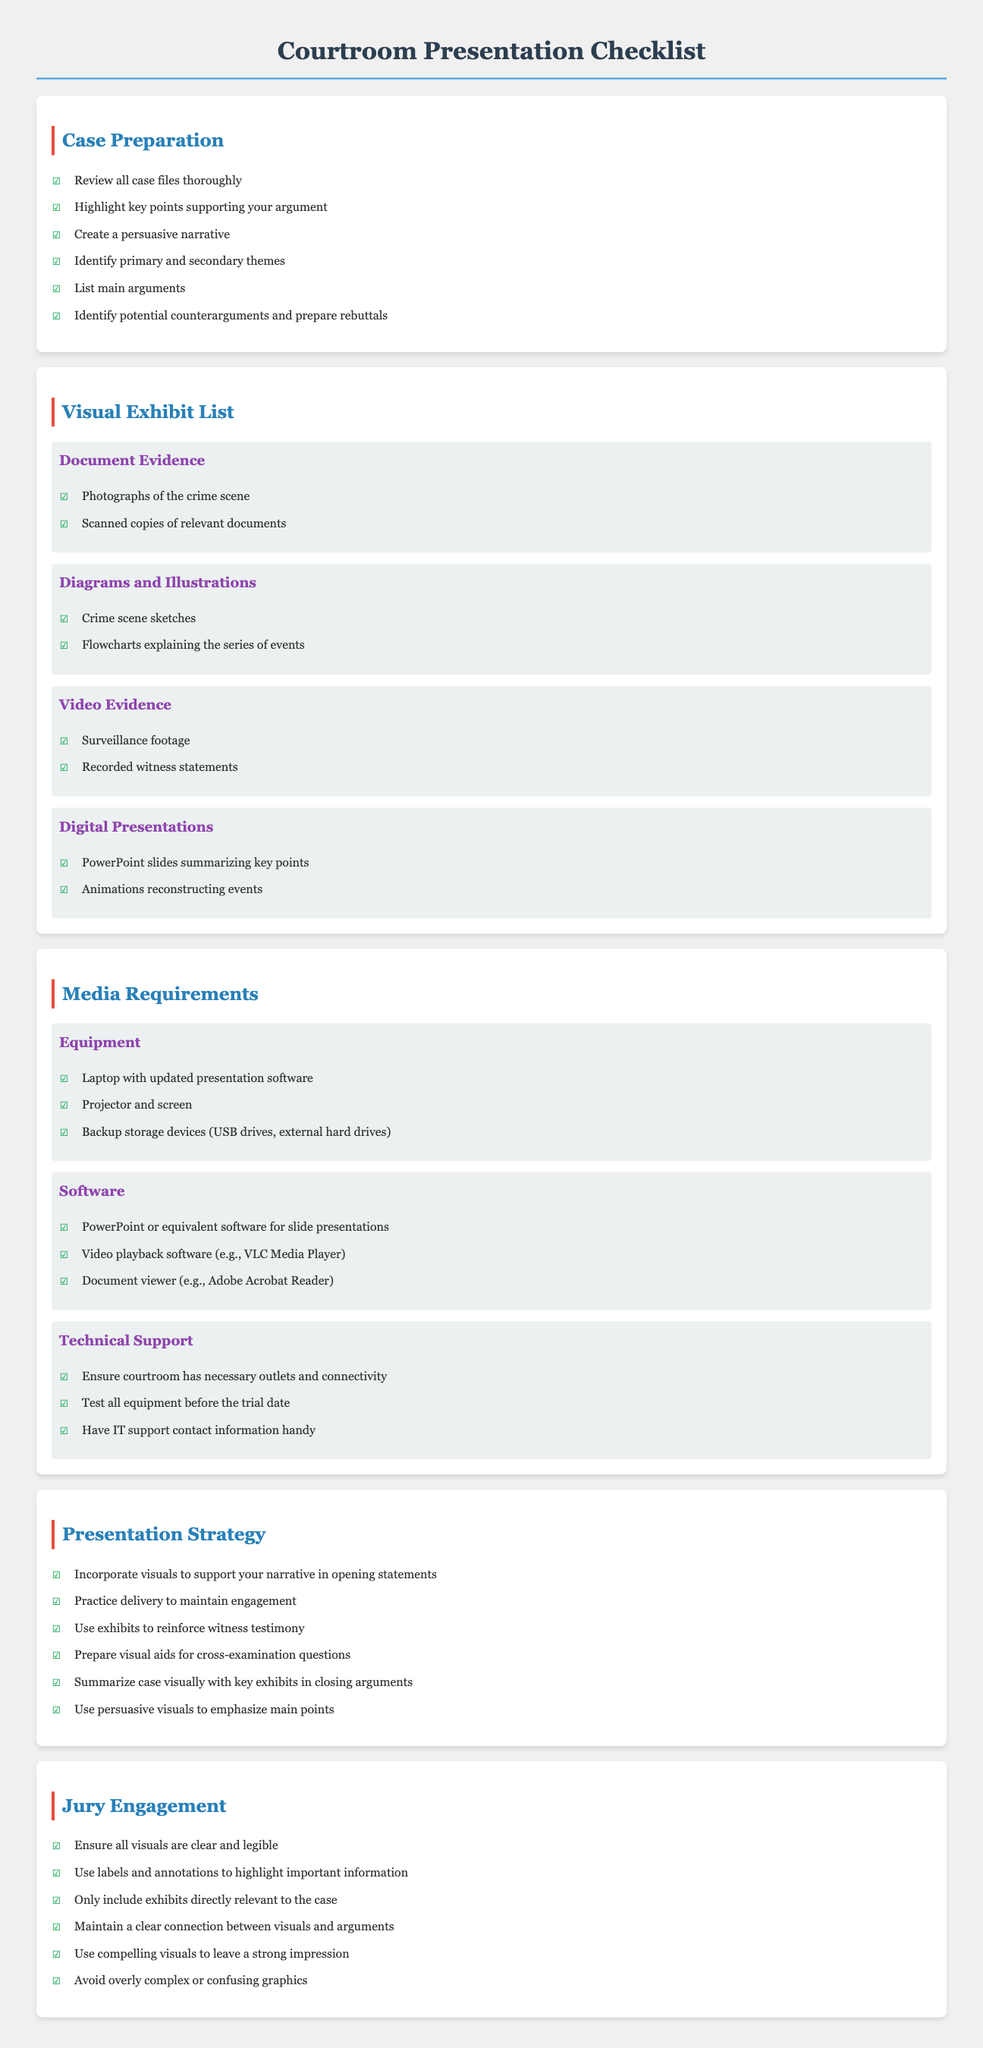What is the title of the document? The title is indicated in the header of the document.
Answer: Courtroom Presentation Checklist How many sections are in the document? The sections are listed in the main body of the document, which shows the distinct areas covered.
Answer: 5 What type of evidence includes photographs? This is found under "Visual Exhibit List" where types of evidence are categorized.
Answer: Document Evidence What piece of software is required for video playback? This is specified under "Software" in the "Media Requirements" section.
Answer: VLC Media Player What is essential for engaging the jury? This is highlighted in the "Jury Engagement" section, which outlines practices for interaction.
Answer: Clear and legible visuals List one item included in the "Equipment" subsection. This can be retrieved from the "Equipment" subsection under "Media Requirements."
Answer: Projector and screen How should visuals be used during opening statements? This is covered in the "Presentation Strategy" section which outlines effective presentation techniques.
Answer: To support your narrative What should be tested before the trial date? This is mentioned in the "Technical Support" subsection under "Media Requirements."
Answer: All equipment Which section discusses summarizing the case visually? The location of this information can be identified through the section headings.
Answer: Presentation Strategy What is one goal of a persuasive narrative? This can be inferred from the "Case Preparation" section focusing on building a compelling case.
Answer: Engage the jury 